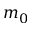<formula> <loc_0><loc_0><loc_500><loc_500>m _ { 0 }</formula> 